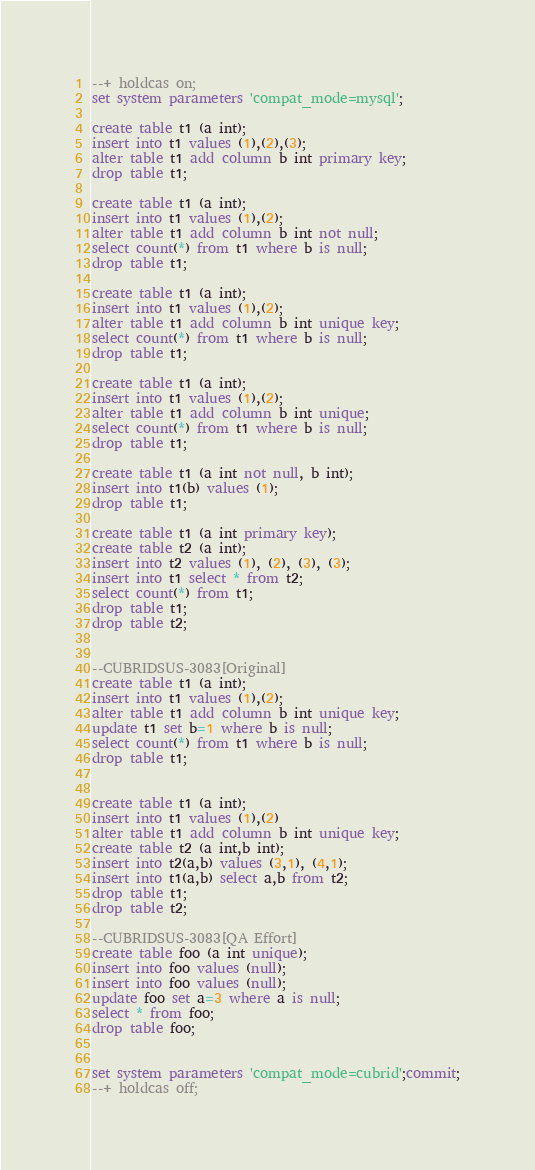<code> <loc_0><loc_0><loc_500><loc_500><_SQL_>--+ holdcas on;
set system parameters 'compat_mode=mysql';

create table t1 (a int);
insert into t1 values (1),(2),(3); 
alter table t1 add column b int primary key; 
drop table t1;

create table t1 (a int);
insert into t1 values (1),(2); 
alter table t1 add column b int not null; 
select count(*) from t1 where b is null;
drop table t1;

create table t1 (a int);
insert into t1 values (1),(2); 
alter table t1 add column b int unique key;
select count(*) from t1 where b is null;
drop table t1;

create table t1 (a int);
insert into t1 values (1),(2); 
alter table t1 add column b int unique; 
select count(*) from t1 where b is null;
drop table t1;

create table t1 (a int not null, b int);
insert into t1(b) values (1);
drop table t1;

create table t1 (a int primary key);
create table t2 (a int);
insert into t2 values (1), (2), (3), (3); 
insert into t1 select * from t2;
select count(*) from t1;
drop table t1;
drop table t2;


--CUBRIDSUS-3083[Original]
create table t1 (a int);
insert into t1 values (1),(2); 
alter table t1 add column b int unique key;
update t1 set b=1 where b is null;
select count(*) from t1 where b is null;
drop table t1;


create table t1 (a int);
insert into t1 values (1),(2)
alter table t1 add column b int unique key;
create table t2 (a int,b int);
insert into t2(a,b) values (3,1), (4,1); 
insert into t1(a,b) select a,b from t2;
drop table t1;
drop table t2;

--CUBRIDSUS-3083[QA Effort]
create table foo (a int unique);
insert into foo values (null);
insert into foo values (null);
update foo set a=3 where a is null; 
select * from foo; 
drop table foo;


set system parameters 'compat_mode=cubrid';commit;
--+ holdcas off;
</code> 